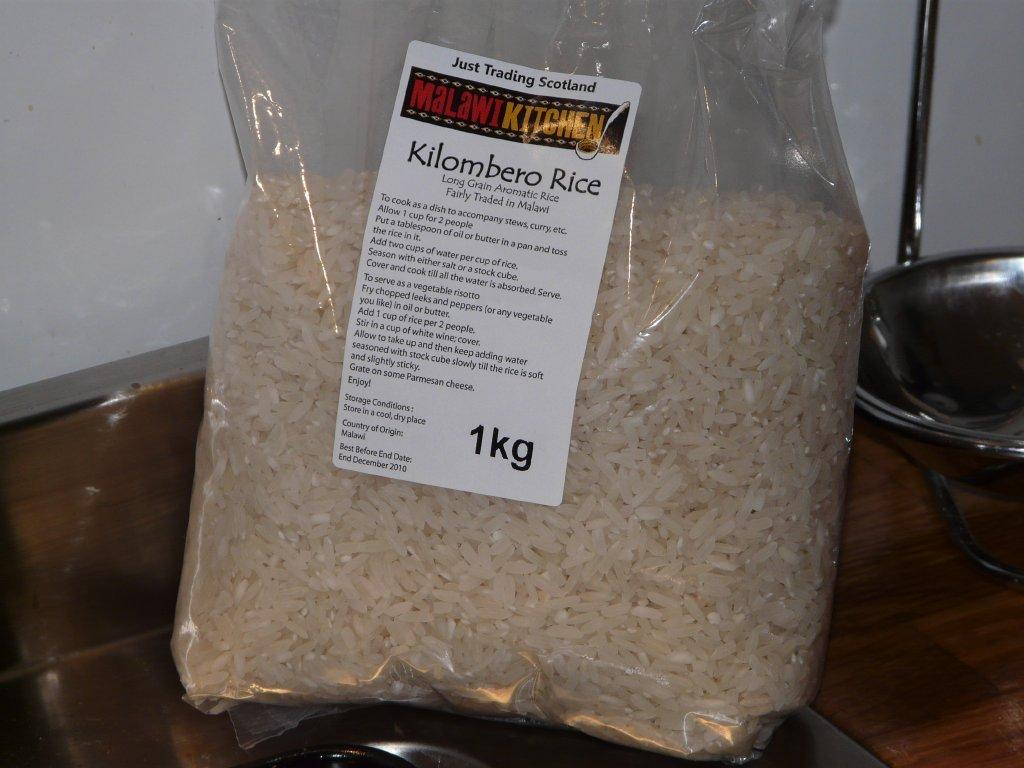What is inside the packet that is visible in the image? There is a packet with rice grains in the image. What is on the packet besides the rice grains? The packet has a sticker with text on it. Can you describe the object on the wooden surface on the right side of the image? Unfortunately, the facts provided do not give enough information to describe the object on the wooden surface. How does the rainstorm affect the rice grains in the image? There is no rainstorm present in the image, so it cannot affect the rice grains. What type of blade is being used to cut the rice grains in the image? There is no blade present in the image, and the rice grains are contained within a packet. 